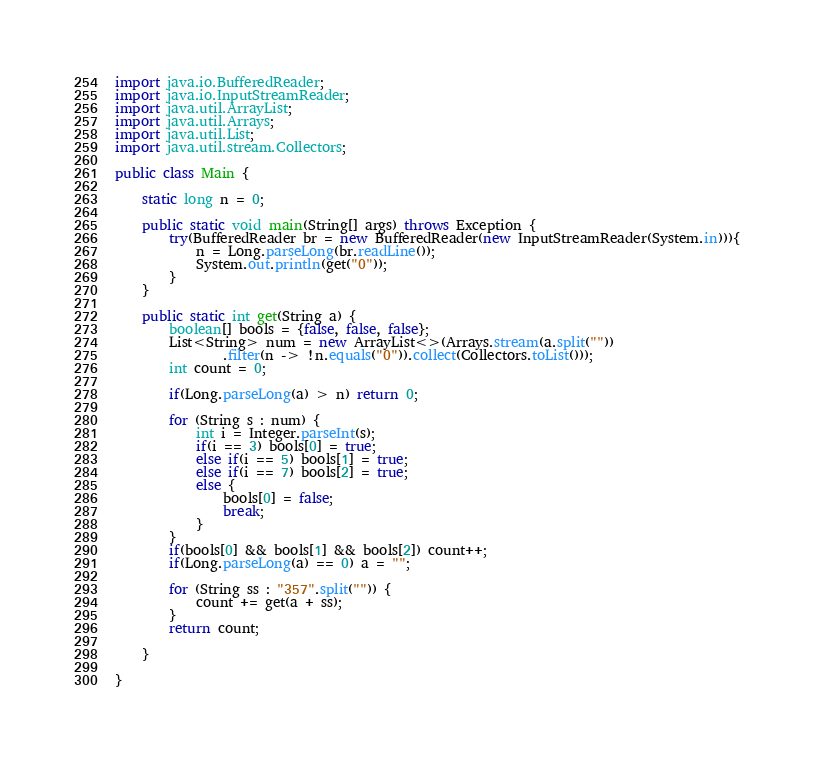<code> <loc_0><loc_0><loc_500><loc_500><_Java_>
import java.io.BufferedReader;
import java.io.InputStreamReader;
import java.util.ArrayList;
import java.util.Arrays;
import java.util.List;
import java.util.stream.Collectors;

public class Main {
	
	static long n = 0;

	public static void main(String[] args) throws Exception {
		try(BufferedReader br = new BufferedReader(new InputStreamReader(System.in))){
			n = Long.parseLong(br.readLine());
			System.out.println(get("0"));
		}
	}
	
	public static int get(String a) {
		boolean[] bools = {false, false, false};
		List<String> num = new ArrayList<>(Arrays.stream(a.split(""))
				.filter(n -> !n.equals("0")).collect(Collectors.toList()));
		int count = 0;
		
		if(Long.parseLong(a) > n) return 0;
		
		for (String s : num) {
			int i = Integer.parseInt(s);
			if(i == 3) bools[0] = true;
			else if(i == 5) bools[1] = true;
			else if(i == 7) bools[2] = true;
			else {
				bools[0] = false;
				break;
			}
		}
		if(bools[0] && bools[1] && bools[2]) count++;
		if(Long.parseLong(a) == 0) a = "";
		
		for (String ss : "357".split("")) {
			count += get(a + ss);
		}
		return count;
		
	}

}
</code> 